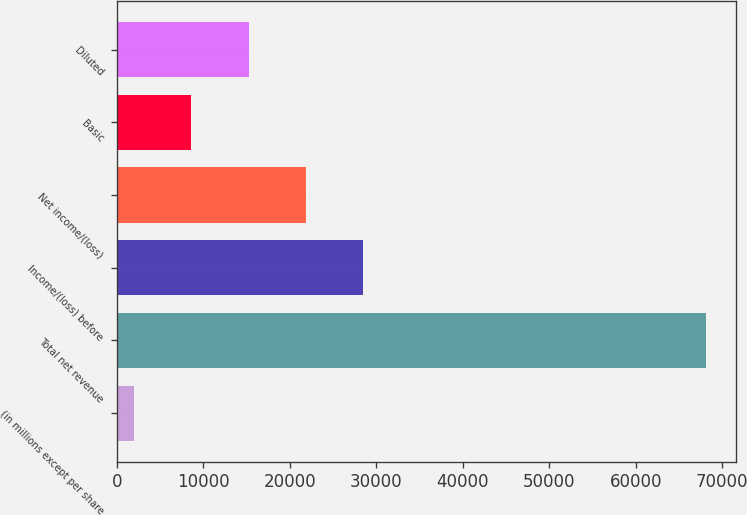Convert chart to OTSL. <chart><loc_0><loc_0><loc_500><loc_500><bar_chart><fcel>(in millions except per share<fcel>Total net revenue<fcel>Income/(loss) before<fcel>Net income/(loss)<fcel>Basic<fcel>Diluted<nl><fcel>2008<fcel>68149<fcel>28464.4<fcel>21850.3<fcel>8622.1<fcel>15236.2<nl></chart> 